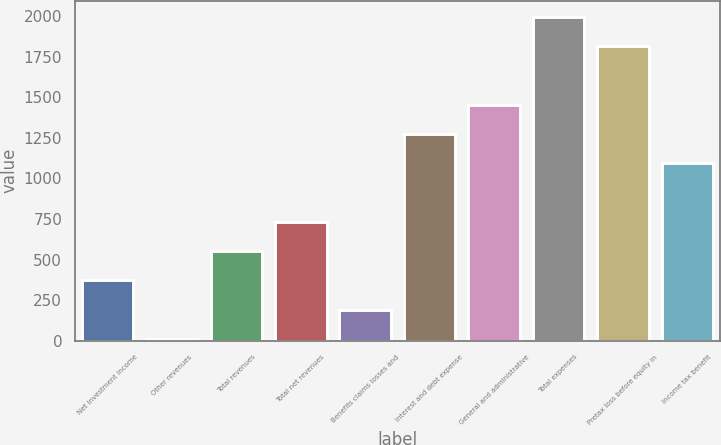Convert chart to OTSL. <chart><loc_0><loc_0><loc_500><loc_500><bar_chart><fcel>Net investment income<fcel>Other revenues<fcel>Total revenues<fcel>Total net revenues<fcel>Benefits claims losses and<fcel>Interest and debt expense<fcel>General and administrative<fcel>Total expenses<fcel>Pretax loss before equity in<fcel>Income tax benefit<nl><fcel>372<fcel>11<fcel>552.5<fcel>733<fcel>191.5<fcel>1274.5<fcel>1455<fcel>1996.5<fcel>1816<fcel>1094<nl></chart> 